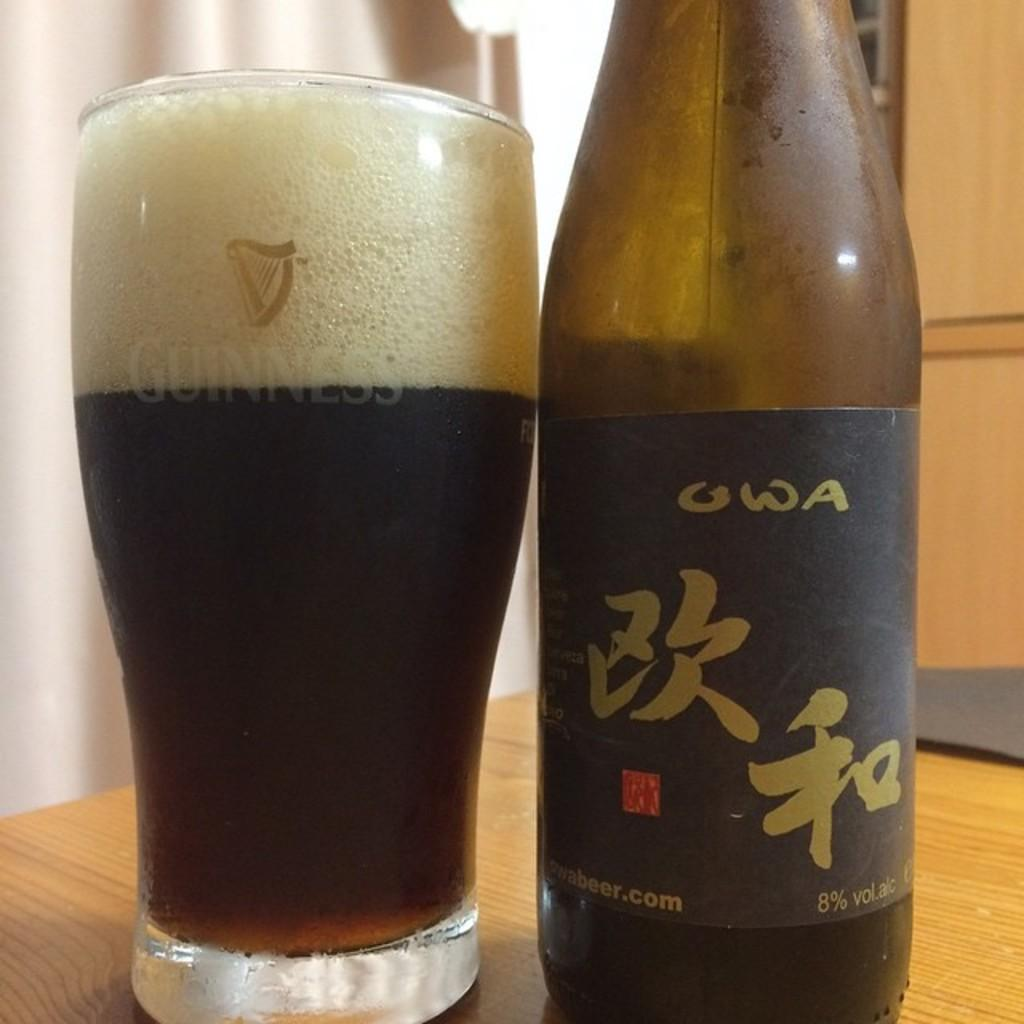<image>
Create a compact narrative representing the image presented. Bottle of alcohol that says OWA on it. next to a cup. 